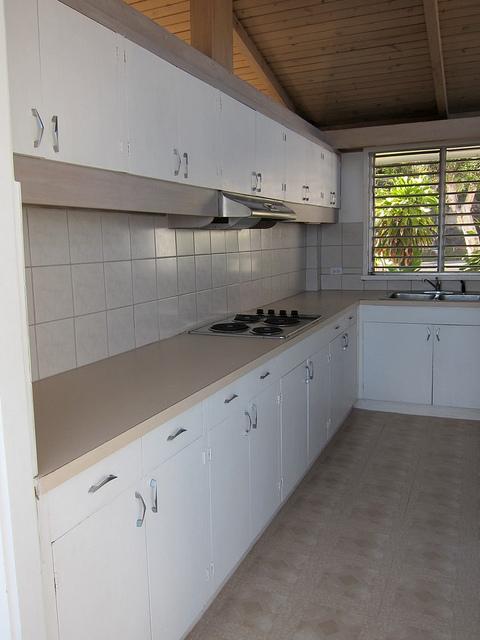Is there a window in this kitchen?
Concise answer only. Yes. Are all the cabinets white?
Answer briefly. Yes. What is normally done in this type of room?
Keep it brief. Cooking. What material is the roof?
Write a very short answer. Wood. Is there a charger device plugged in?
Answer briefly. No. Is this a large kitchen?
Quick response, please. Yes. What is this room?
Answer briefly. Kitchen. 